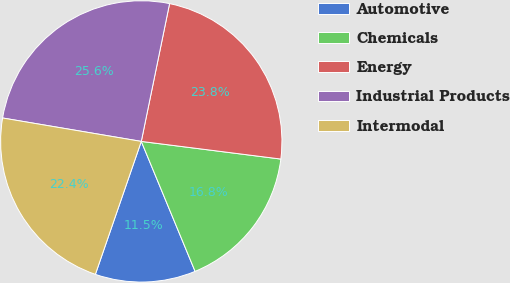Convert chart. <chart><loc_0><loc_0><loc_500><loc_500><pie_chart><fcel>Automotive<fcel>Chemicals<fcel>Energy<fcel>Industrial Products<fcel>Intermodal<nl><fcel>11.54%<fcel>16.75%<fcel>23.78%<fcel>25.56%<fcel>22.37%<nl></chart> 